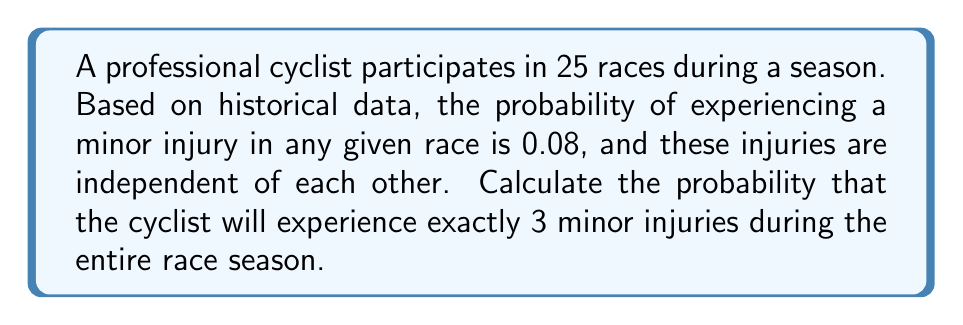Show me your answer to this math problem. To solve this problem, we can use the Binomial probability distribution, as we have a fixed number of independent trials (races) with two possible outcomes for each trial (injury or no injury).

The Binomial probability mass function is given by:

$$ P(X = k) = \binom{n}{k} p^k (1-p)^{n-k} $$

Where:
- $n$ is the number of trials (races)
- $k$ is the number of successes (injuries)
- $p$ is the probability of success (injury) on each trial

Given:
- $n = 25$ (races in the season)
- $k = 3$ (exactly 3 injuries)
- $p = 0.08$ (probability of injury in each race)

Step 1: Calculate the binomial coefficient $\binom{n}{k}$
$$ \binom{25}{3} = \frac{25!}{3!(25-3)!} = \frac{25!}{3!22!} = 2300 $$

Step 2: Calculate $p^k$
$$ 0.08^3 = 0.000512 $$

Step 3: Calculate $(1-p)^{n-k}$
$$ (1-0.08)^{25-3} = 0.92^{22} \approx 0.1631 $$

Step 4: Multiply the results from steps 1, 2, and 3
$$ P(X = 3) = 2300 \times 0.000512 \times 0.1631 \approx 0.1915 $$

Therefore, the probability of the cyclist experiencing exactly 3 minor injuries during the 25-race season is approximately 0.1915 or 19.15%.
Answer: $P(X = 3) \approx 0.1915$ or 19.15% 